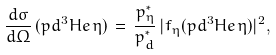<formula> <loc_0><loc_0><loc_500><loc_500>\frac { d \sigma } { d \Omega } \, ( p d ^ { 3 } H e \, \eta ) \, = \, \frac { p _ { \eta } ^ { * } } { p _ { d } ^ { * } } \, | f _ { \eta } ( p d ^ { 3 } H e \, \eta ) | ^ { 2 } ,</formula> 